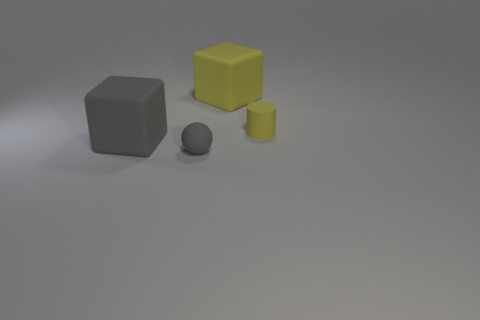The gray object that is to the left of the small matte object in front of the tiny rubber thing that is behind the sphere is made of what material? The gray object to the left of the small yellow cube, and in front of the tiny cylinder behind the gray sphere, appears to have a matte surface similar to rubber or plastic, which would be consistent with its visual appearance and common manufacturing materials for such objects. 